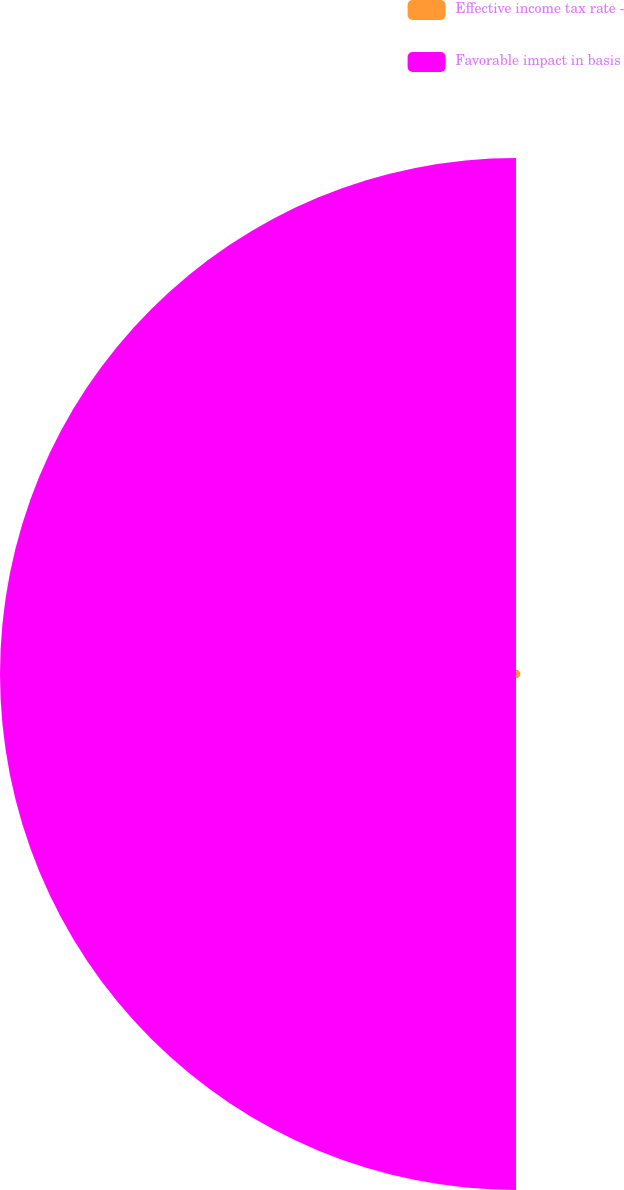Convert chart. <chart><loc_0><loc_0><loc_500><loc_500><pie_chart><fcel>Effective income tax rate -<fcel>Favorable impact in basis<nl><fcel>0.83%<fcel>99.17%<nl></chart> 